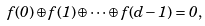Convert formula to latex. <formula><loc_0><loc_0><loc_500><loc_500>f ( 0 ) \oplus f ( 1 ) \oplus \cdots \oplus f ( d - 1 ) = 0 ,</formula> 